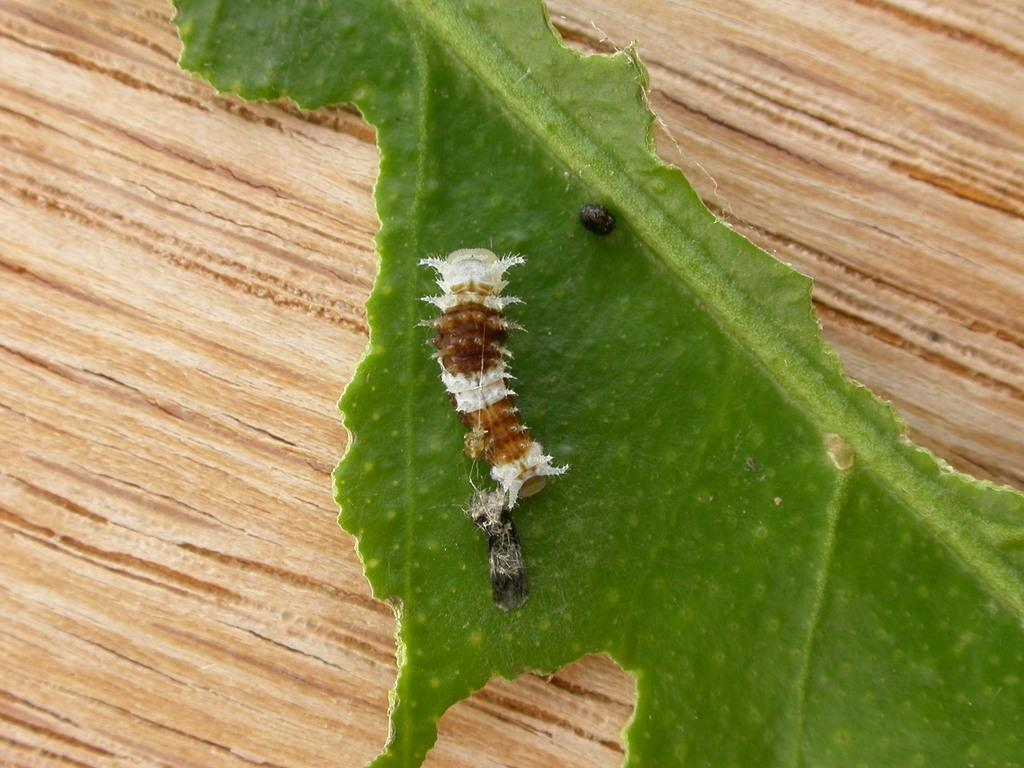What is the main object in the image? There is a table in the image. What is on top of the table? There is a leaf on the table. What is on the leaf? There is a caterpillar on the leaf. What type of hands can be seen holding the caterpillar in the image? A: There are no hands visible in the image; the caterpillar is on the leaf by itself. 